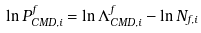Convert formula to latex. <formula><loc_0><loc_0><loc_500><loc_500>\ln P _ { C M D , i } ^ { f } = \ln \Lambda _ { C M D , i } ^ { f } - \ln N _ { f , i }</formula> 